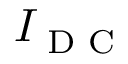<formula> <loc_0><loc_0><loc_500><loc_500>I _ { D C }</formula> 